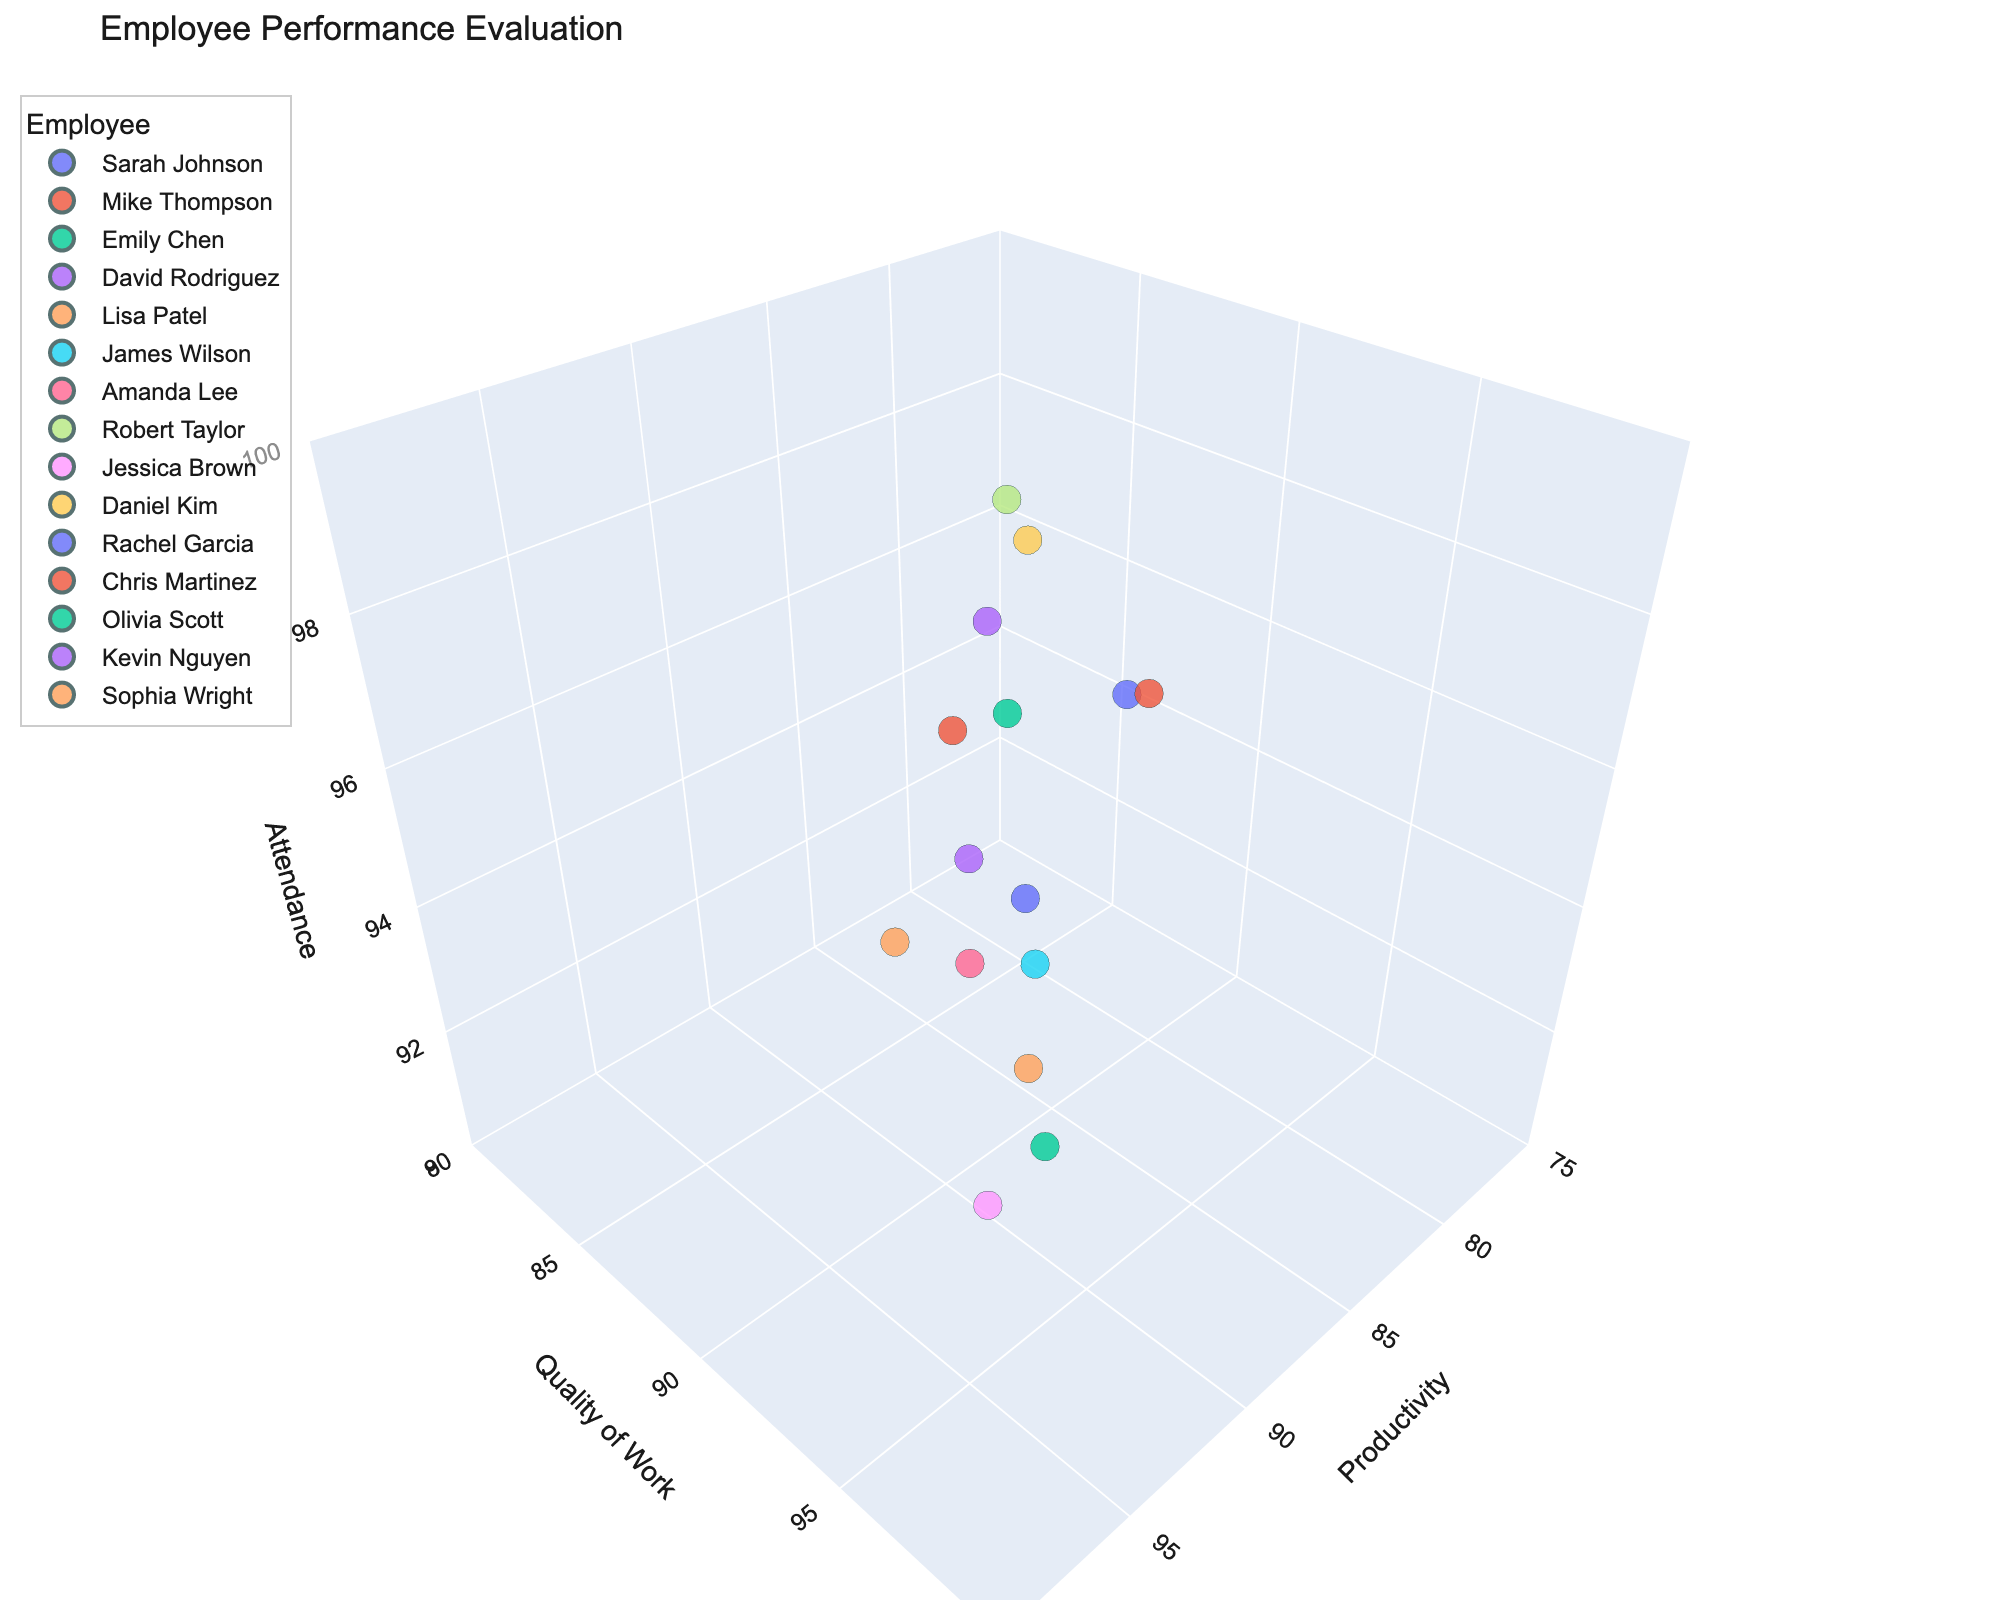What's the title of the figure? The title of the figure is displayed at the top of the plot.
Answer: Employee Performance Evaluation How many data points are there in the plot? Each employee represents one data point. By counting the points listed in the hover_data or visually inspecting the plot, we see there are 15 data points.
Answer: 15 What's the range of the Productivity axis? The range of the Productivity axis is configured to be from 75 to 100.
Answer: 75 to 100 Which employee has the highest Quality of Work score? By looking at the z-axis values (or by identifying the highest dot along the Quality of Work axis and checking the hover data), we see that Sophia Wright has a Quality of Work score of 96.
Answer: Sophia Wright Who has better attendance: Sarah Johnson or Robert Taylor? By comparing their positions along the Attendance axis or checking their hover data, Sarah Johnson has an Attendance of 97 while Robert Taylor has an Attendance of 99.
Answer: Robert Taylor What is the average Productivity score of all employees? Sum the Productivity scores of all employees (85 + 78 + 92 + 88 + 95 + 82 + 90 + 86 + 93 + 80 + 89 + 87 + 91 + 84 + 94) and divide by the number of employees (15). This gives the average as (85 + 78 + 92 + 88 + 95 + 82 + 90 + 86 + 93 + 80 + 89 + 87 + 91 + 84 + 94)/15 = 87.33
Answer: 87.33 Who has higher overall performance across all metrics: Amanda Lee or Olivia Scott? Compare their values in all three dimensions: Productivity, Quality of Work, and Attendance. Amanda Lee: (90, 91, 94) vs. Olivia Scott: (91, 93, 98). Olivia has higher values in Productivity, Quality of Work, and Attendance.
Answer: Olivia Scott What is the combined total of Attendance scores for Lisa Patel and David Rodriguez? Sum their Attendance scores from the hover data: Lisa Patel (96) + David Rodriguez (98) = 194.
Answer: 194 Who has the lowest Quality of Work score? By locating the lowest point along the Quality of Work axis and checking the hover data, Daniel Kim has a Quality of Work score of 85.
Answer: Daniel Kim Is there any employee who has the same score in both Productivity and Attendance? Scan the hover data to check if any employee has identical scores in both dimensions. No such match is found.
Answer: No 